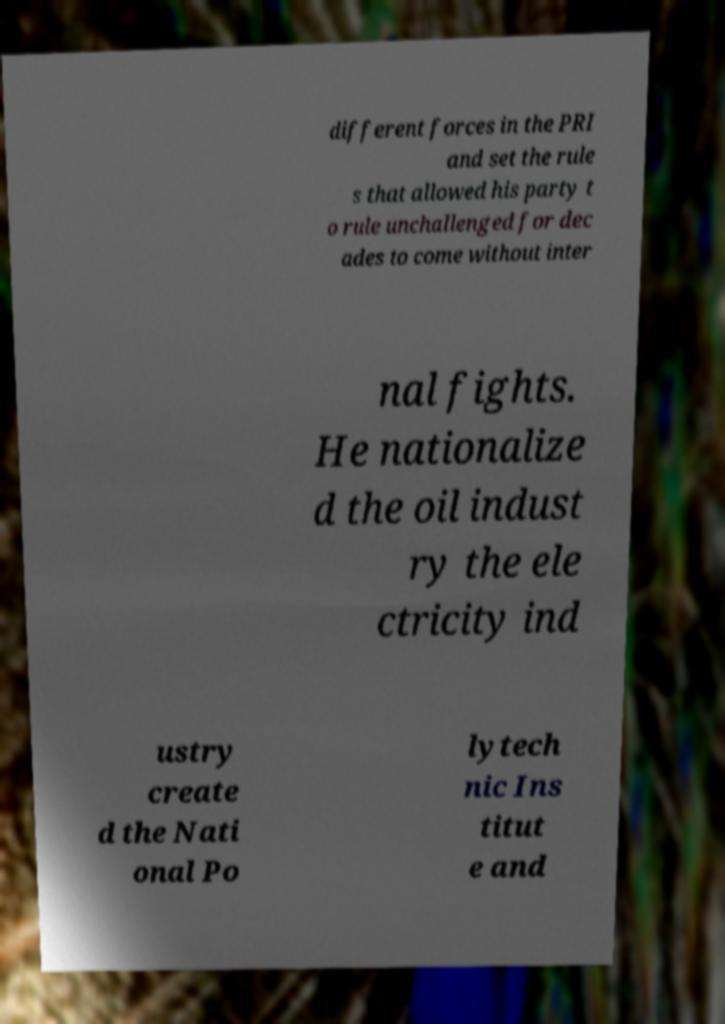Could you extract and type out the text from this image? different forces in the PRI and set the rule s that allowed his party t o rule unchallenged for dec ades to come without inter nal fights. He nationalize d the oil indust ry the ele ctricity ind ustry create d the Nati onal Po lytech nic Ins titut e and 